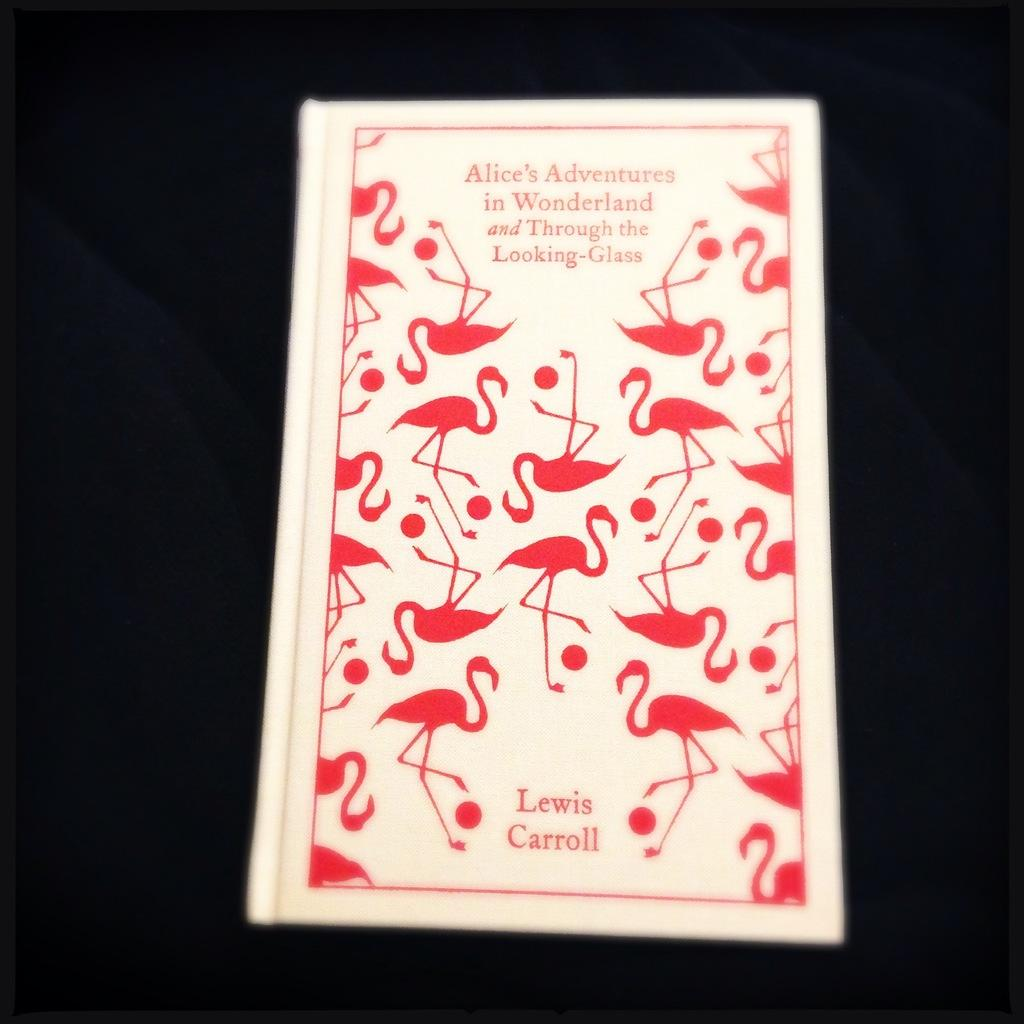<image>
Create a compact narrative representing the image presented. an old copy of Alice in wonderland is shown with the author shown at the bottom. 